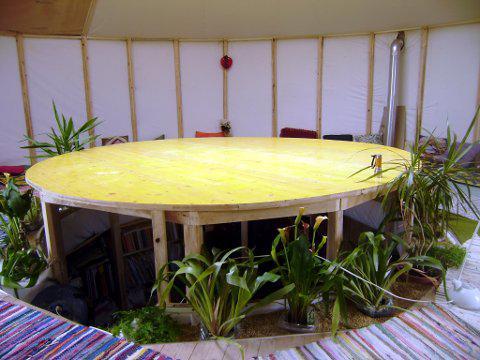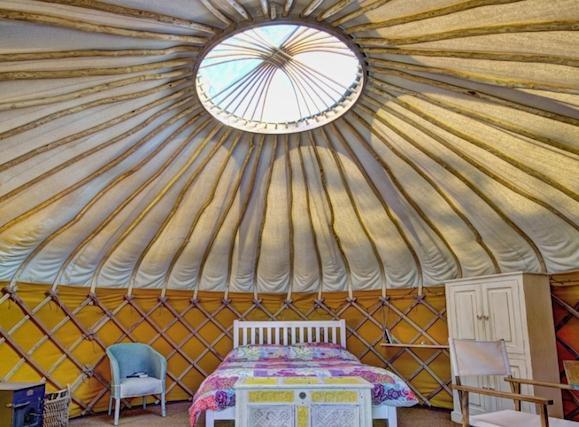The first image is the image on the left, the second image is the image on the right. Evaluate the accuracy of this statement regarding the images: "The left image features at least one plant with long green leaves near something resembling a table.". Is it true? Answer yes or no. Yes. The first image is the image on the left, the second image is the image on the right. Given the left and right images, does the statement "One of the images contains the exterior of a yurt." hold true? Answer yes or no. No. 